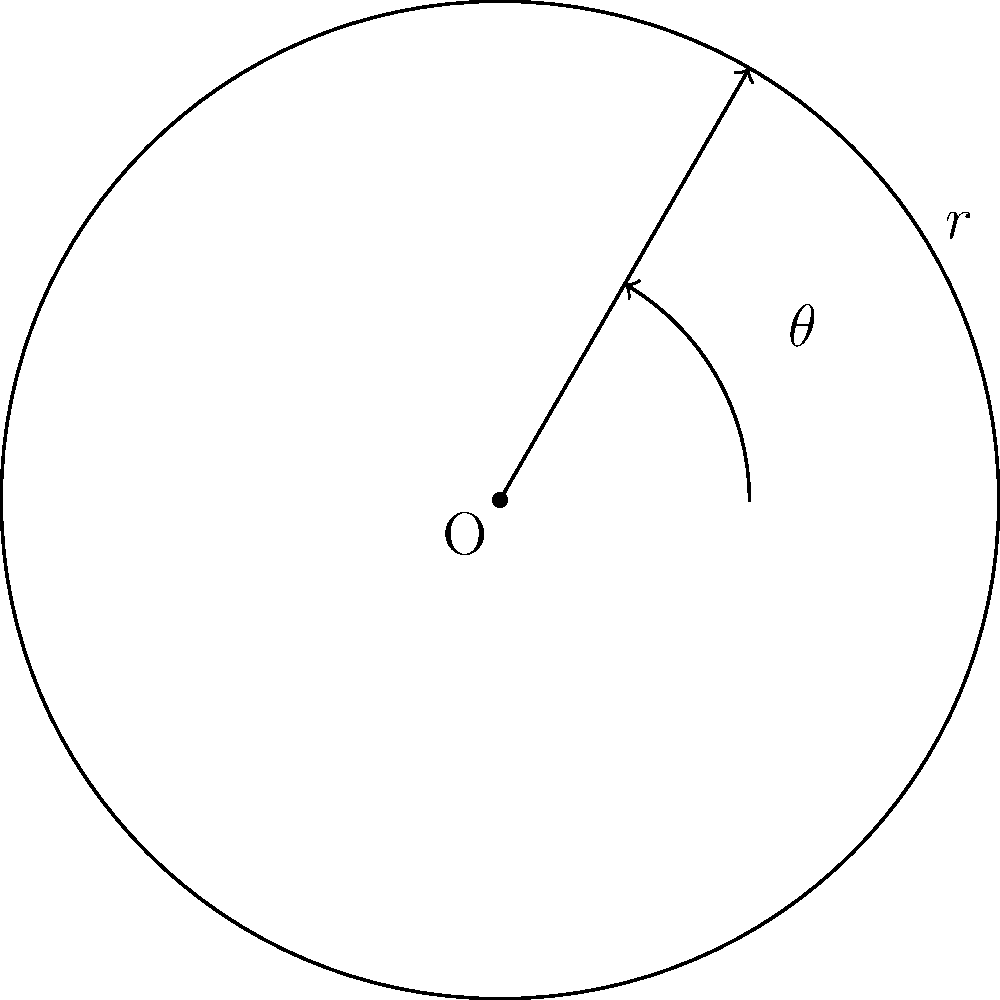In a hyperbolic plane with constant negative curvature $K=-1/a^2$, the area of a circle with radius $r$ is given by $A=4\pi a^2 \sinh^2(r/2a)$. If Doug Hoffman's race car is traveling on a circular track with a radius of $3a$ in this hyperbolic plane, what is the area of the track in terms of $a^2$? Let's approach this step-by-step:

1) We are given the formula for the area of a circle in a hyperbolic plane:
   $A = 4\pi a^2 \sinh^2(r/2a)$

2) We are also given that the radius of the track is $r = 3a$

3) Let's substitute $r = 3a$ into the formula:
   $A = 4\pi a^2 \sinh^2(3a/2a)$
   $A = 4\pi a^2 \sinh^2(3/2)$

4) Now, we need to calculate $\sinh^2(3/2)$:
   $\sinh(3/2) \approx 2.1292794550948173$
   $\sinh^2(3/2) \approx 4.5338534572870806$

5) Substituting this value back into our equation:
   $A \approx 4\pi a^2 (4.5338534572870806)$
   $A \approx 56.9469933040486 a^2$

6) Rounding to two decimal places for a more concise answer:
   $A \approx 56.95 a^2$

Thus, the area of the track is approximately $56.95 a^2$.
Answer: $56.95 a^2$ 